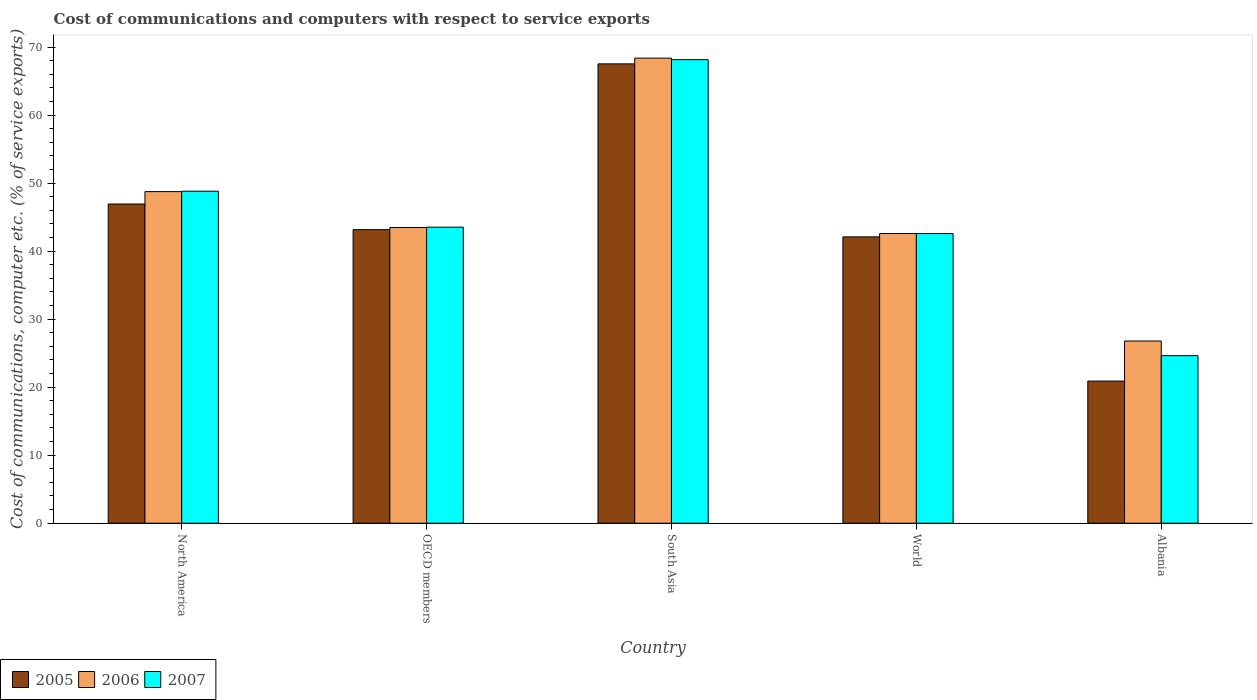How many different coloured bars are there?
Keep it short and to the point. 3. How many groups of bars are there?
Your answer should be compact. 5. Are the number of bars on each tick of the X-axis equal?
Offer a very short reply. Yes. How many bars are there on the 1st tick from the left?
Your answer should be very brief. 3. What is the label of the 5th group of bars from the left?
Give a very brief answer. Albania. What is the cost of communications and computers in 2006 in Albania?
Offer a very short reply. 26.79. Across all countries, what is the maximum cost of communications and computers in 2005?
Provide a short and direct response. 67.54. Across all countries, what is the minimum cost of communications and computers in 2005?
Your answer should be compact. 20.9. In which country was the cost of communications and computers in 2007 minimum?
Your response must be concise. Albania. What is the total cost of communications and computers in 2006 in the graph?
Keep it short and to the point. 230.01. What is the difference between the cost of communications and computers in 2007 in North America and that in OECD members?
Give a very brief answer. 5.29. What is the difference between the cost of communications and computers in 2006 in South Asia and the cost of communications and computers in 2005 in North America?
Your answer should be compact. 21.45. What is the average cost of communications and computers in 2006 per country?
Your answer should be very brief. 46. What is the difference between the cost of communications and computers of/in 2007 and cost of communications and computers of/in 2005 in South Asia?
Ensure brevity in your answer.  0.62. In how many countries, is the cost of communications and computers in 2007 greater than 44 %?
Keep it short and to the point. 2. What is the ratio of the cost of communications and computers in 2006 in OECD members to that in South Asia?
Keep it short and to the point. 0.64. What is the difference between the highest and the second highest cost of communications and computers in 2006?
Keep it short and to the point. 5.28. What is the difference between the highest and the lowest cost of communications and computers in 2006?
Provide a succinct answer. 41.59. In how many countries, is the cost of communications and computers in 2006 greater than the average cost of communications and computers in 2006 taken over all countries?
Provide a short and direct response. 2. Is the sum of the cost of communications and computers in 2006 in North America and South Asia greater than the maximum cost of communications and computers in 2005 across all countries?
Your response must be concise. Yes. Is it the case that in every country, the sum of the cost of communications and computers in 2007 and cost of communications and computers in 2005 is greater than the cost of communications and computers in 2006?
Ensure brevity in your answer.  Yes. Does the graph contain grids?
Offer a very short reply. No. How many legend labels are there?
Give a very brief answer. 3. What is the title of the graph?
Your answer should be compact. Cost of communications and computers with respect to service exports. Does "1994" appear as one of the legend labels in the graph?
Offer a very short reply. No. What is the label or title of the X-axis?
Offer a very short reply. Country. What is the label or title of the Y-axis?
Make the answer very short. Cost of communications, computer etc. (% of service exports). What is the Cost of communications, computer etc. (% of service exports) of 2005 in North America?
Give a very brief answer. 46.93. What is the Cost of communications, computer etc. (% of service exports) of 2006 in North America?
Your answer should be very brief. 48.76. What is the Cost of communications, computer etc. (% of service exports) in 2007 in North America?
Keep it short and to the point. 48.82. What is the Cost of communications, computer etc. (% of service exports) of 2005 in OECD members?
Your response must be concise. 43.17. What is the Cost of communications, computer etc. (% of service exports) of 2006 in OECD members?
Provide a short and direct response. 43.48. What is the Cost of communications, computer etc. (% of service exports) in 2007 in OECD members?
Make the answer very short. 43.53. What is the Cost of communications, computer etc. (% of service exports) in 2005 in South Asia?
Offer a very short reply. 67.54. What is the Cost of communications, computer etc. (% of service exports) in 2006 in South Asia?
Give a very brief answer. 68.39. What is the Cost of communications, computer etc. (% of service exports) in 2007 in South Asia?
Your response must be concise. 68.16. What is the Cost of communications, computer etc. (% of service exports) of 2005 in World?
Give a very brief answer. 42.1. What is the Cost of communications, computer etc. (% of service exports) of 2006 in World?
Make the answer very short. 42.59. What is the Cost of communications, computer etc. (% of service exports) in 2007 in World?
Offer a terse response. 42.59. What is the Cost of communications, computer etc. (% of service exports) in 2005 in Albania?
Give a very brief answer. 20.9. What is the Cost of communications, computer etc. (% of service exports) in 2006 in Albania?
Provide a short and direct response. 26.79. What is the Cost of communications, computer etc. (% of service exports) in 2007 in Albania?
Keep it short and to the point. 24.63. Across all countries, what is the maximum Cost of communications, computer etc. (% of service exports) of 2005?
Give a very brief answer. 67.54. Across all countries, what is the maximum Cost of communications, computer etc. (% of service exports) of 2006?
Offer a very short reply. 68.39. Across all countries, what is the maximum Cost of communications, computer etc. (% of service exports) in 2007?
Give a very brief answer. 68.16. Across all countries, what is the minimum Cost of communications, computer etc. (% of service exports) in 2005?
Provide a succinct answer. 20.9. Across all countries, what is the minimum Cost of communications, computer etc. (% of service exports) of 2006?
Your response must be concise. 26.79. Across all countries, what is the minimum Cost of communications, computer etc. (% of service exports) of 2007?
Your answer should be compact. 24.63. What is the total Cost of communications, computer etc. (% of service exports) of 2005 in the graph?
Your answer should be very brief. 220.65. What is the total Cost of communications, computer etc. (% of service exports) of 2006 in the graph?
Give a very brief answer. 230.01. What is the total Cost of communications, computer etc. (% of service exports) of 2007 in the graph?
Offer a very short reply. 227.73. What is the difference between the Cost of communications, computer etc. (% of service exports) in 2005 in North America and that in OECD members?
Give a very brief answer. 3.77. What is the difference between the Cost of communications, computer etc. (% of service exports) of 2006 in North America and that in OECD members?
Give a very brief answer. 5.28. What is the difference between the Cost of communications, computer etc. (% of service exports) in 2007 in North America and that in OECD members?
Your response must be concise. 5.29. What is the difference between the Cost of communications, computer etc. (% of service exports) of 2005 in North America and that in South Asia?
Offer a very short reply. -20.61. What is the difference between the Cost of communications, computer etc. (% of service exports) of 2006 in North America and that in South Asia?
Make the answer very short. -19.63. What is the difference between the Cost of communications, computer etc. (% of service exports) in 2007 in North America and that in South Asia?
Your response must be concise. -19.34. What is the difference between the Cost of communications, computer etc. (% of service exports) in 2005 in North America and that in World?
Your answer should be compact. 4.83. What is the difference between the Cost of communications, computer etc. (% of service exports) of 2006 in North America and that in World?
Your answer should be very brief. 6.16. What is the difference between the Cost of communications, computer etc. (% of service exports) in 2007 in North America and that in World?
Give a very brief answer. 6.23. What is the difference between the Cost of communications, computer etc. (% of service exports) in 2005 in North America and that in Albania?
Make the answer very short. 26.03. What is the difference between the Cost of communications, computer etc. (% of service exports) of 2006 in North America and that in Albania?
Keep it short and to the point. 21.97. What is the difference between the Cost of communications, computer etc. (% of service exports) of 2007 in North America and that in Albania?
Offer a terse response. 24.19. What is the difference between the Cost of communications, computer etc. (% of service exports) in 2005 in OECD members and that in South Asia?
Your answer should be compact. -24.37. What is the difference between the Cost of communications, computer etc. (% of service exports) in 2006 in OECD members and that in South Asia?
Your response must be concise. -24.9. What is the difference between the Cost of communications, computer etc. (% of service exports) of 2007 in OECD members and that in South Asia?
Keep it short and to the point. -24.63. What is the difference between the Cost of communications, computer etc. (% of service exports) in 2005 in OECD members and that in World?
Your response must be concise. 1.06. What is the difference between the Cost of communications, computer etc. (% of service exports) of 2006 in OECD members and that in World?
Provide a succinct answer. 0.89. What is the difference between the Cost of communications, computer etc. (% of service exports) of 2007 in OECD members and that in World?
Make the answer very short. 0.94. What is the difference between the Cost of communications, computer etc. (% of service exports) of 2005 in OECD members and that in Albania?
Provide a short and direct response. 22.27. What is the difference between the Cost of communications, computer etc. (% of service exports) of 2006 in OECD members and that in Albania?
Your response must be concise. 16.69. What is the difference between the Cost of communications, computer etc. (% of service exports) in 2007 in OECD members and that in Albania?
Provide a succinct answer. 18.9. What is the difference between the Cost of communications, computer etc. (% of service exports) of 2005 in South Asia and that in World?
Keep it short and to the point. 25.44. What is the difference between the Cost of communications, computer etc. (% of service exports) of 2006 in South Asia and that in World?
Offer a terse response. 25.79. What is the difference between the Cost of communications, computer etc. (% of service exports) of 2007 in South Asia and that in World?
Your answer should be very brief. 25.57. What is the difference between the Cost of communications, computer etc. (% of service exports) of 2005 in South Asia and that in Albania?
Provide a short and direct response. 46.64. What is the difference between the Cost of communications, computer etc. (% of service exports) of 2006 in South Asia and that in Albania?
Your answer should be compact. 41.59. What is the difference between the Cost of communications, computer etc. (% of service exports) in 2007 in South Asia and that in Albania?
Offer a terse response. 43.53. What is the difference between the Cost of communications, computer etc. (% of service exports) in 2005 in World and that in Albania?
Provide a short and direct response. 21.2. What is the difference between the Cost of communications, computer etc. (% of service exports) in 2006 in World and that in Albania?
Offer a terse response. 15.8. What is the difference between the Cost of communications, computer etc. (% of service exports) of 2007 in World and that in Albania?
Offer a very short reply. 17.96. What is the difference between the Cost of communications, computer etc. (% of service exports) in 2005 in North America and the Cost of communications, computer etc. (% of service exports) in 2006 in OECD members?
Keep it short and to the point. 3.45. What is the difference between the Cost of communications, computer etc. (% of service exports) in 2005 in North America and the Cost of communications, computer etc. (% of service exports) in 2007 in OECD members?
Your response must be concise. 3.41. What is the difference between the Cost of communications, computer etc. (% of service exports) in 2006 in North America and the Cost of communications, computer etc. (% of service exports) in 2007 in OECD members?
Provide a short and direct response. 5.23. What is the difference between the Cost of communications, computer etc. (% of service exports) in 2005 in North America and the Cost of communications, computer etc. (% of service exports) in 2006 in South Asia?
Provide a short and direct response. -21.45. What is the difference between the Cost of communications, computer etc. (% of service exports) of 2005 in North America and the Cost of communications, computer etc. (% of service exports) of 2007 in South Asia?
Provide a succinct answer. -21.23. What is the difference between the Cost of communications, computer etc. (% of service exports) of 2006 in North America and the Cost of communications, computer etc. (% of service exports) of 2007 in South Asia?
Your answer should be compact. -19.4. What is the difference between the Cost of communications, computer etc. (% of service exports) of 2005 in North America and the Cost of communications, computer etc. (% of service exports) of 2006 in World?
Provide a succinct answer. 4.34. What is the difference between the Cost of communications, computer etc. (% of service exports) in 2005 in North America and the Cost of communications, computer etc. (% of service exports) in 2007 in World?
Offer a terse response. 4.34. What is the difference between the Cost of communications, computer etc. (% of service exports) of 2006 in North America and the Cost of communications, computer etc. (% of service exports) of 2007 in World?
Provide a succinct answer. 6.16. What is the difference between the Cost of communications, computer etc. (% of service exports) of 2005 in North America and the Cost of communications, computer etc. (% of service exports) of 2006 in Albania?
Your answer should be very brief. 20.14. What is the difference between the Cost of communications, computer etc. (% of service exports) in 2005 in North America and the Cost of communications, computer etc. (% of service exports) in 2007 in Albania?
Offer a terse response. 22.3. What is the difference between the Cost of communications, computer etc. (% of service exports) in 2006 in North America and the Cost of communications, computer etc. (% of service exports) in 2007 in Albania?
Your response must be concise. 24.13. What is the difference between the Cost of communications, computer etc. (% of service exports) of 2005 in OECD members and the Cost of communications, computer etc. (% of service exports) of 2006 in South Asia?
Your response must be concise. -25.22. What is the difference between the Cost of communications, computer etc. (% of service exports) of 2005 in OECD members and the Cost of communications, computer etc. (% of service exports) of 2007 in South Asia?
Ensure brevity in your answer.  -24.99. What is the difference between the Cost of communications, computer etc. (% of service exports) in 2006 in OECD members and the Cost of communications, computer etc. (% of service exports) in 2007 in South Asia?
Make the answer very short. -24.68. What is the difference between the Cost of communications, computer etc. (% of service exports) of 2005 in OECD members and the Cost of communications, computer etc. (% of service exports) of 2006 in World?
Your response must be concise. 0.57. What is the difference between the Cost of communications, computer etc. (% of service exports) of 2005 in OECD members and the Cost of communications, computer etc. (% of service exports) of 2007 in World?
Offer a terse response. 0.57. What is the difference between the Cost of communications, computer etc. (% of service exports) in 2006 in OECD members and the Cost of communications, computer etc. (% of service exports) in 2007 in World?
Your answer should be compact. 0.89. What is the difference between the Cost of communications, computer etc. (% of service exports) of 2005 in OECD members and the Cost of communications, computer etc. (% of service exports) of 2006 in Albania?
Your response must be concise. 16.38. What is the difference between the Cost of communications, computer etc. (% of service exports) in 2005 in OECD members and the Cost of communications, computer etc. (% of service exports) in 2007 in Albania?
Ensure brevity in your answer.  18.53. What is the difference between the Cost of communications, computer etc. (% of service exports) of 2006 in OECD members and the Cost of communications, computer etc. (% of service exports) of 2007 in Albania?
Offer a very short reply. 18.85. What is the difference between the Cost of communications, computer etc. (% of service exports) in 2005 in South Asia and the Cost of communications, computer etc. (% of service exports) in 2006 in World?
Make the answer very short. 24.95. What is the difference between the Cost of communications, computer etc. (% of service exports) in 2005 in South Asia and the Cost of communications, computer etc. (% of service exports) in 2007 in World?
Provide a succinct answer. 24.95. What is the difference between the Cost of communications, computer etc. (% of service exports) of 2006 in South Asia and the Cost of communications, computer etc. (% of service exports) of 2007 in World?
Give a very brief answer. 25.79. What is the difference between the Cost of communications, computer etc. (% of service exports) in 2005 in South Asia and the Cost of communications, computer etc. (% of service exports) in 2006 in Albania?
Your answer should be compact. 40.75. What is the difference between the Cost of communications, computer etc. (% of service exports) of 2005 in South Asia and the Cost of communications, computer etc. (% of service exports) of 2007 in Albania?
Make the answer very short. 42.91. What is the difference between the Cost of communications, computer etc. (% of service exports) of 2006 in South Asia and the Cost of communications, computer etc. (% of service exports) of 2007 in Albania?
Provide a short and direct response. 43.75. What is the difference between the Cost of communications, computer etc. (% of service exports) in 2005 in World and the Cost of communications, computer etc. (% of service exports) in 2006 in Albania?
Keep it short and to the point. 15.31. What is the difference between the Cost of communications, computer etc. (% of service exports) of 2005 in World and the Cost of communications, computer etc. (% of service exports) of 2007 in Albania?
Offer a very short reply. 17.47. What is the difference between the Cost of communications, computer etc. (% of service exports) in 2006 in World and the Cost of communications, computer etc. (% of service exports) in 2007 in Albania?
Offer a very short reply. 17.96. What is the average Cost of communications, computer etc. (% of service exports) of 2005 per country?
Offer a very short reply. 44.13. What is the average Cost of communications, computer etc. (% of service exports) in 2006 per country?
Offer a very short reply. 46. What is the average Cost of communications, computer etc. (% of service exports) in 2007 per country?
Your response must be concise. 45.55. What is the difference between the Cost of communications, computer etc. (% of service exports) in 2005 and Cost of communications, computer etc. (% of service exports) in 2006 in North America?
Offer a terse response. -1.82. What is the difference between the Cost of communications, computer etc. (% of service exports) in 2005 and Cost of communications, computer etc. (% of service exports) in 2007 in North America?
Offer a very short reply. -1.88. What is the difference between the Cost of communications, computer etc. (% of service exports) in 2006 and Cost of communications, computer etc. (% of service exports) in 2007 in North America?
Offer a terse response. -0.06. What is the difference between the Cost of communications, computer etc. (% of service exports) of 2005 and Cost of communications, computer etc. (% of service exports) of 2006 in OECD members?
Keep it short and to the point. -0.32. What is the difference between the Cost of communications, computer etc. (% of service exports) of 2005 and Cost of communications, computer etc. (% of service exports) of 2007 in OECD members?
Ensure brevity in your answer.  -0.36. What is the difference between the Cost of communications, computer etc. (% of service exports) of 2006 and Cost of communications, computer etc. (% of service exports) of 2007 in OECD members?
Offer a terse response. -0.05. What is the difference between the Cost of communications, computer etc. (% of service exports) of 2005 and Cost of communications, computer etc. (% of service exports) of 2006 in South Asia?
Keep it short and to the point. -0.84. What is the difference between the Cost of communications, computer etc. (% of service exports) in 2005 and Cost of communications, computer etc. (% of service exports) in 2007 in South Asia?
Give a very brief answer. -0.62. What is the difference between the Cost of communications, computer etc. (% of service exports) in 2006 and Cost of communications, computer etc. (% of service exports) in 2007 in South Asia?
Provide a succinct answer. 0.22. What is the difference between the Cost of communications, computer etc. (% of service exports) of 2005 and Cost of communications, computer etc. (% of service exports) of 2006 in World?
Offer a terse response. -0.49. What is the difference between the Cost of communications, computer etc. (% of service exports) in 2005 and Cost of communications, computer etc. (% of service exports) in 2007 in World?
Provide a short and direct response. -0.49. What is the difference between the Cost of communications, computer etc. (% of service exports) in 2006 and Cost of communications, computer etc. (% of service exports) in 2007 in World?
Offer a terse response. 0. What is the difference between the Cost of communications, computer etc. (% of service exports) of 2005 and Cost of communications, computer etc. (% of service exports) of 2006 in Albania?
Your response must be concise. -5.89. What is the difference between the Cost of communications, computer etc. (% of service exports) in 2005 and Cost of communications, computer etc. (% of service exports) in 2007 in Albania?
Your response must be concise. -3.73. What is the difference between the Cost of communications, computer etc. (% of service exports) of 2006 and Cost of communications, computer etc. (% of service exports) of 2007 in Albania?
Your response must be concise. 2.16. What is the ratio of the Cost of communications, computer etc. (% of service exports) in 2005 in North America to that in OECD members?
Give a very brief answer. 1.09. What is the ratio of the Cost of communications, computer etc. (% of service exports) of 2006 in North America to that in OECD members?
Offer a terse response. 1.12. What is the ratio of the Cost of communications, computer etc. (% of service exports) of 2007 in North America to that in OECD members?
Provide a succinct answer. 1.12. What is the ratio of the Cost of communications, computer etc. (% of service exports) in 2005 in North America to that in South Asia?
Make the answer very short. 0.69. What is the ratio of the Cost of communications, computer etc. (% of service exports) of 2006 in North America to that in South Asia?
Keep it short and to the point. 0.71. What is the ratio of the Cost of communications, computer etc. (% of service exports) of 2007 in North America to that in South Asia?
Offer a terse response. 0.72. What is the ratio of the Cost of communications, computer etc. (% of service exports) in 2005 in North America to that in World?
Your answer should be compact. 1.11. What is the ratio of the Cost of communications, computer etc. (% of service exports) in 2006 in North America to that in World?
Give a very brief answer. 1.14. What is the ratio of the Cost of communications, computer etc. (% of service exports) in 2007 in North America to that in World?
Make the answer very short. 1.15. What is the ratio of the Cost of communications, computer etc. (% of service exports) of 2005 in North America to that in Albania?
Offer a very short reply. 2.25. What is the ratio of the Cost of communications, computer etc. (% of service exports) in 2006 in North America to that in Albania?
Make the answer very short. 1.82. What is the ratio of the Cost of communications, computer etc. (% of service exports) in 2007 in North America to that in Albania?
Make the answer very short. 1.98. What is the ratio of the Cost of communications, computer etc. (% of service exports) in 2005 in OECD members to that in South Asia?
Offer a terse response. 0.64. What is the ratio of the Cost of communications, computer etc. (% of service exports) of 2006 in OECD members to that in South Asia?
Your response must be concise. 0.64. What is the ratio of the Cost of communications, computer etc. (% of service exports) of 2007 in OECD members to that in South Asia?
Provide a succinct answer. 0.64. What is the ratio of the Cost of communications, computer etc. (% of service exports) of 2005 in OECD members to that in World?
Your response must be concise. 1.03. What is the ratio of the Cost of communications, computer etc. (% of service exports) of 2006 in OECD members to that in World?
Your answer should be very brief. 1.02. What is the ratio of the Cost of communications, computer etc. (% of service exports) of 2007 in OECD members to that in World?
Provide a short and direct response. 1.02. What is the ratio of the Cost of communications, computer etc. (% of service exports) in 2005 in OECD members to that in Albania?
Offer a terse response. 2.07. What is the ratio of the Cost of communications, computer etc. (% of service exports) of 2006 in OECD members to that in Albania?
Make the answer very short. 1.62. What is the ratio of the Cost of communications, computer etc. (% of service exports) of 2007 in OECD members to that in Albania?
Your response must be concise. 1.77. What is the ratio of the Cost of communications, computer etc. (% of service exports) in 2005 in South Asia to that in World?
Offer a terse response. 1.6. What is the ratio of the Cost of communications, computer etc. (% of service exports) of 2006 in South Asia to that in World?
Your answer should be compact. 1.61. What is the ratio of the Cost of communications, computer etc. (% of service exports) in 2007 in South Asia to that in World?
Provide a succinct answer. 1.6. What is the ratio of the Cost of communications, computer etc. (% of service exports) in 2005 in South Asia to that in Albania?
Your answer should be compact. 3.23. What is the ratio of the Cost of communications, computer etc. (% of service exports) of 2006 in South Asia to that in Albania?
Offer a very short reply. 2.55. What is the ratio of the Cost of communications, computer etc. (% of service exports) of 2007 in South Asia to that in Albania?
Offer a very short reply. 2.77. What is the ratio of the Cost of communications, computer etc. (% of service exports) of 2005 in World to that in Albania?
Provide a short and direct response. 2.01. What is the ratio of the Cost of communications, computer etc. (% of service exports) in 2006 in World to that in Albania?
Make the answer very short. 1.59. What is the ratio of the Cost of communications, computer etc. (% of service exports) in 2007 in World to that in Albania?
Make the answer very short. 1.73. What is the difference between the highest and the second highest Cost of communications, computer etc. (% of service exports) in 2005?
Provide a short and direct response. 20.61. What is the difference between the highest and the second highest Cost of communications, computer etc. (% of service exports) of 2006?
Keep it short and to the point. 19.63. What is the difference between the highest and the second highest Cost of communications, computer etc. (% of service exports) of 2007?
Your answer should be compact. 19.34. What is the difference between the highest and the lowest Cost of communications, computer etc. (% of service exports) in 2005?
Your response must be concise. 46.64. What is the difference between the highest and the lowest Cost of communications, computer etc. (% of service exports) in 2006?
Ensure brevity in your answer.  41.59. What is the difference between the highest and the lowest Cost of communications, computer etc. (% of service exports) in 2007?
Provide a succinct answer. 43.53. 